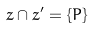Convert formula to latex. <formula><loc_0><loc_0><loc_500><loc_500>z \cap z ^ { \prime } = \{ P \}</formula> 